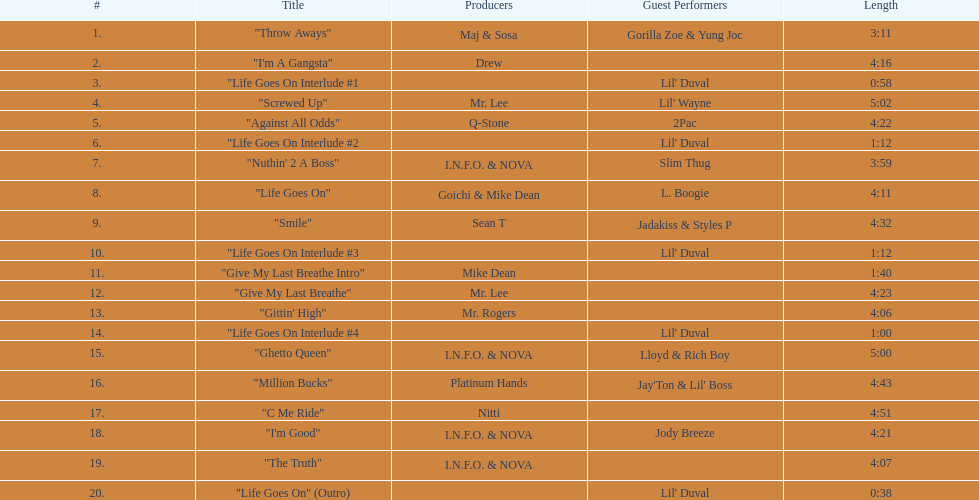What is the length of track 11? 1:40. 